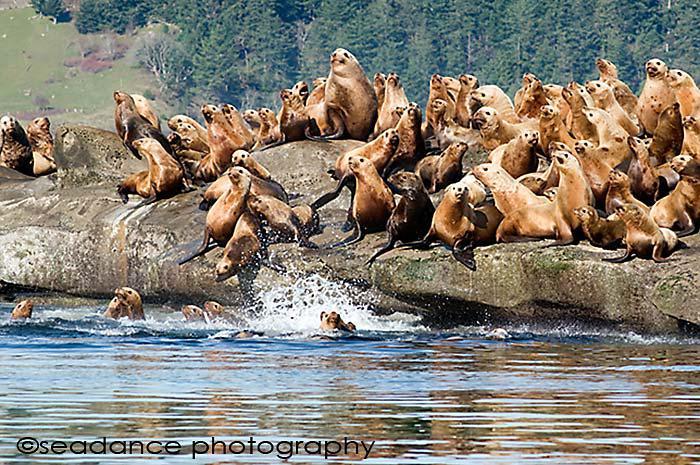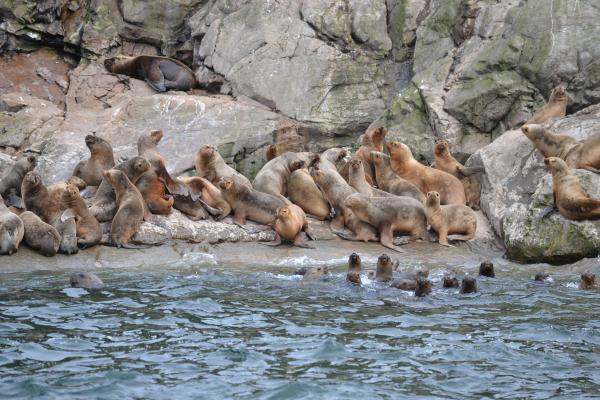The first image is the image on the left, the second image is the image on the right. Given the left and right images, does the statement "All seals in the right image are out of the water." hold true? Answer yes or no. No. The first image is the image on the left, the second image is the image on the right. For the images displayed, is the sentence "Both images show masses of seals on natural rock formations above the water." factually correct? Answer yes or no. Yes. 